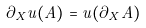Convert formula to latex. <formula><loc_0><loc_0><loc_500><loc_500>\partial _ { X } u ( A ) = u ( \partial _ { X } A )</formula> 